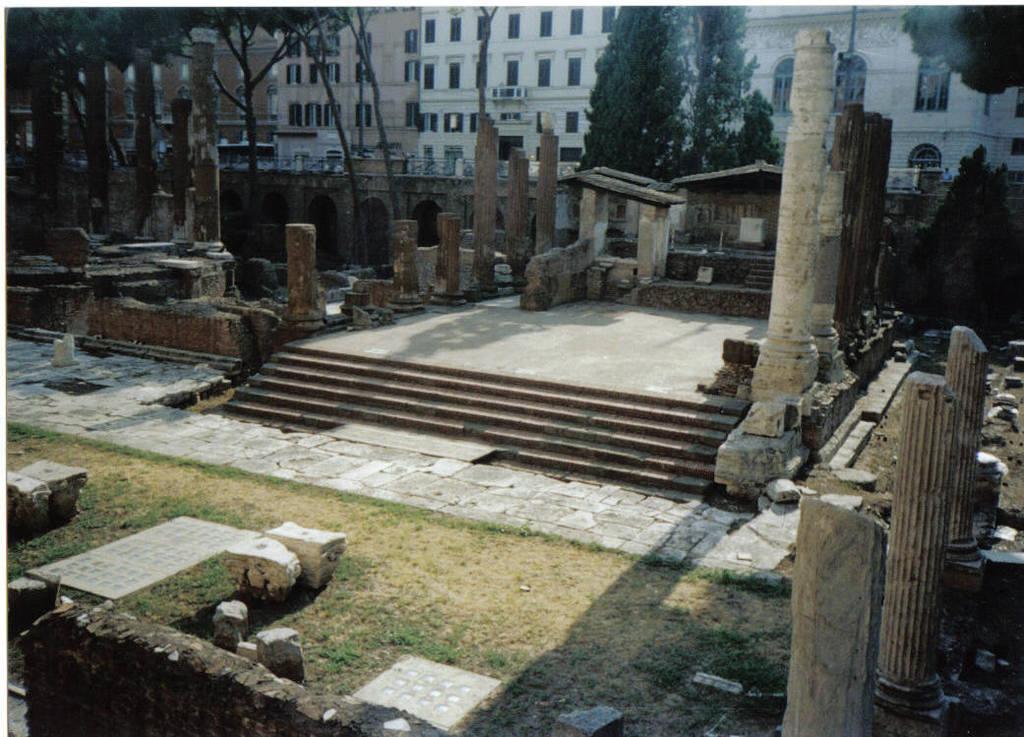How would you summarize this image in a sentence or two? This is an outside view. At the bottom of the image I can see few rocks on the ground. In the middle of the image I can see a stage. On both sides of this there are some pillars and I can see few broken pieces of the pillars on the ground. In the background there are some trees and buildings. 